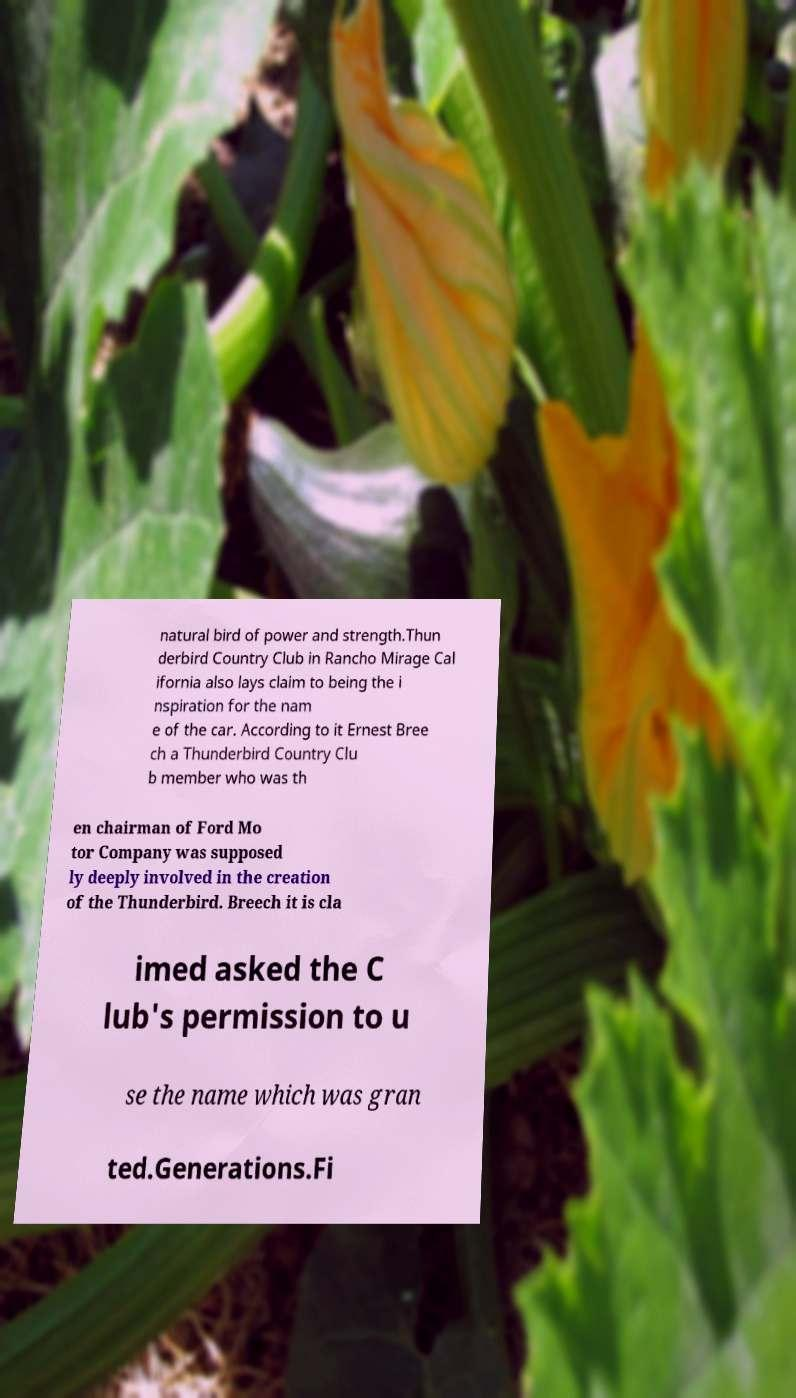Could you extract and type out the text from this image? natural bird of power and strength.Thun derbird Country Club in Rancho Mirage Cal ifornia also lays claim to being the i nspiration for the nam e of the car. According to it Ernest Bree ch a Thunderbird Country Clu b member who was th en chairman of Ford Mo tor Company was supposed ly deeply involved in the creation of the Thunderbird. Breech it is cla imed asked the C lub's permission to u se the name which was gran ted.Generations.Fi 